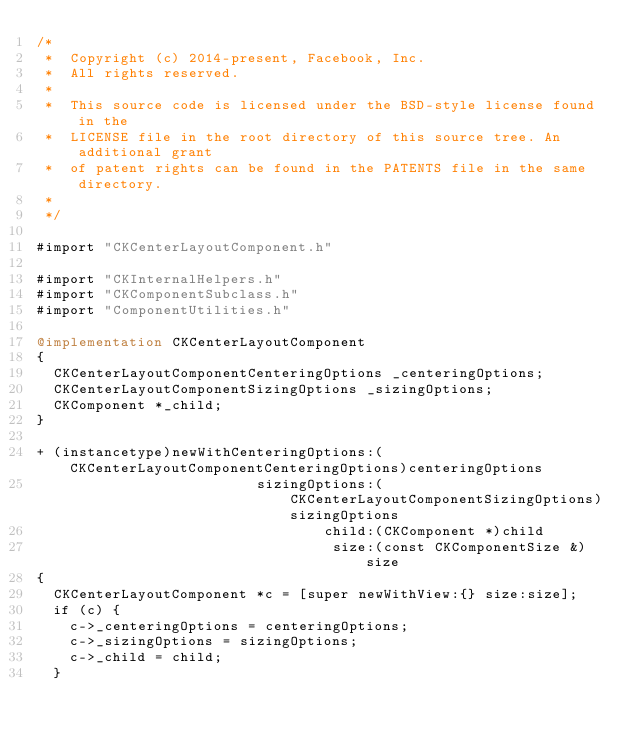<code> <loc_0><loc_0><loc_500><loc_500><_ObjectiveC_>/*
 *  Copyright (c) 2014-present, Facebook, Inc.
 *  All rights reserved.
 *
 *  This source code is licensed under the BSD-style license found in the
 *  LICENSE file in the root directory of this source tree. An additional grant
 *  of patent rights can be found in the PATENTS file in the same directory.
 *
 */

#import "CKCenterLayoutComponent.h"

#import "CKInternalHelpers.h"
#import "CKComponentSubclass.h"
#import "ComponentUtilities.h"

@implementation CKCenterLayoutComponent
{
  CKCenterLayoutComponentCenteringOptions _centeringOptions;
  CKCenterLayoutComponentSizingOptions _sizingOptions;
  CKComponent *_child;
}

+ (instancetype)newWithCenteringOptions:(CKCenterLayoutComponentCenteringOptions)centeringOptions
                          sizingOptions:(CKCenterLayoutComponentSizingOptions)sizingOptions
                                  child:(CKComponent *)child
                                   size:(const CKComponentSize &)size
{
  CKCenterLayoutComponent *c = [super newWithView:{} size:size];
  if (c) {
    c->_centeringOptions = centeringOptions;
    c->_sizingOptions = sizingOptions;
    c->_child = child;
  }</code> 